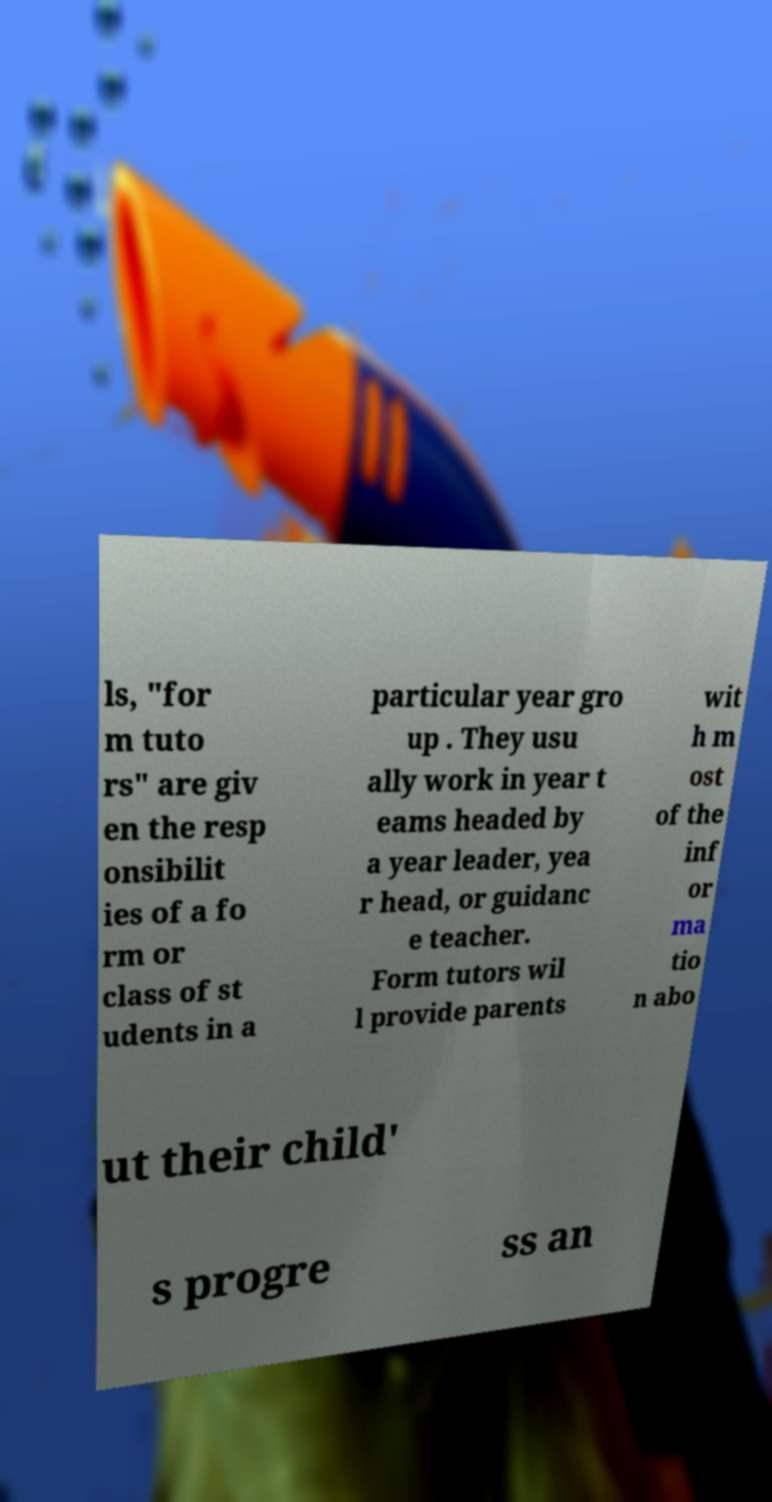Can you accurately transcribe the text from the provided image for me? ls, "for m tuto rs" are giv en the resp onsibilit ies of a fo rm or class of st udents in a particular year gro up . They usu ally work in year t eams headed by a year leader, yea r head, or guidanc e teacher. Form tutors wil l provide parents wit h m ost of the inf or ma tio n abo ut their child' s progre ss an 